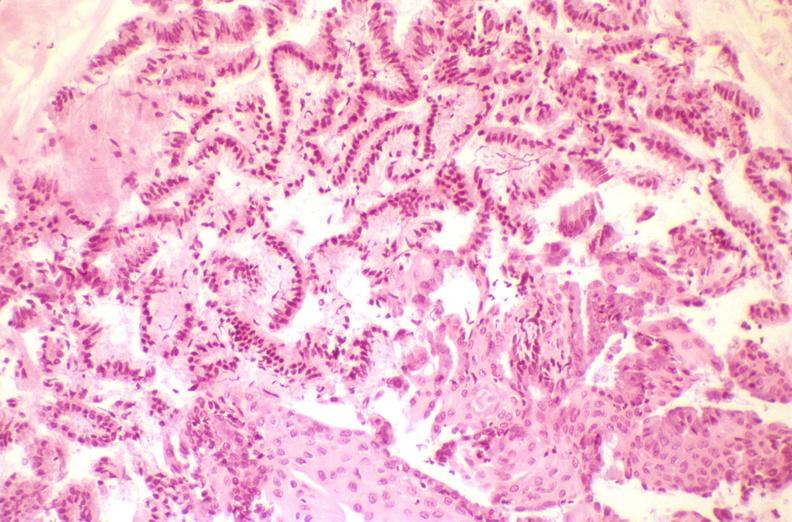s macerated stillborn present?
Answer the question using a single word or phrase. No 